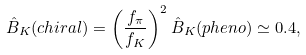<formula> <loc_0><loc_0><loc_500><loc_500>\hat { B } _ { K } ( c h i r a l ) = \left ( \frac { f _ { \pi } } { f _ { K } } \right ) ^ { 2 } \hat { B } _ { K } ( p h e n o ) \simeq 0 . 4 ,</formula> 